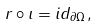<formula> <loc_0><loc_0><loc_500><loc_500>r \circ \iota = i d _ { \partial \Omega } ,</formula> 